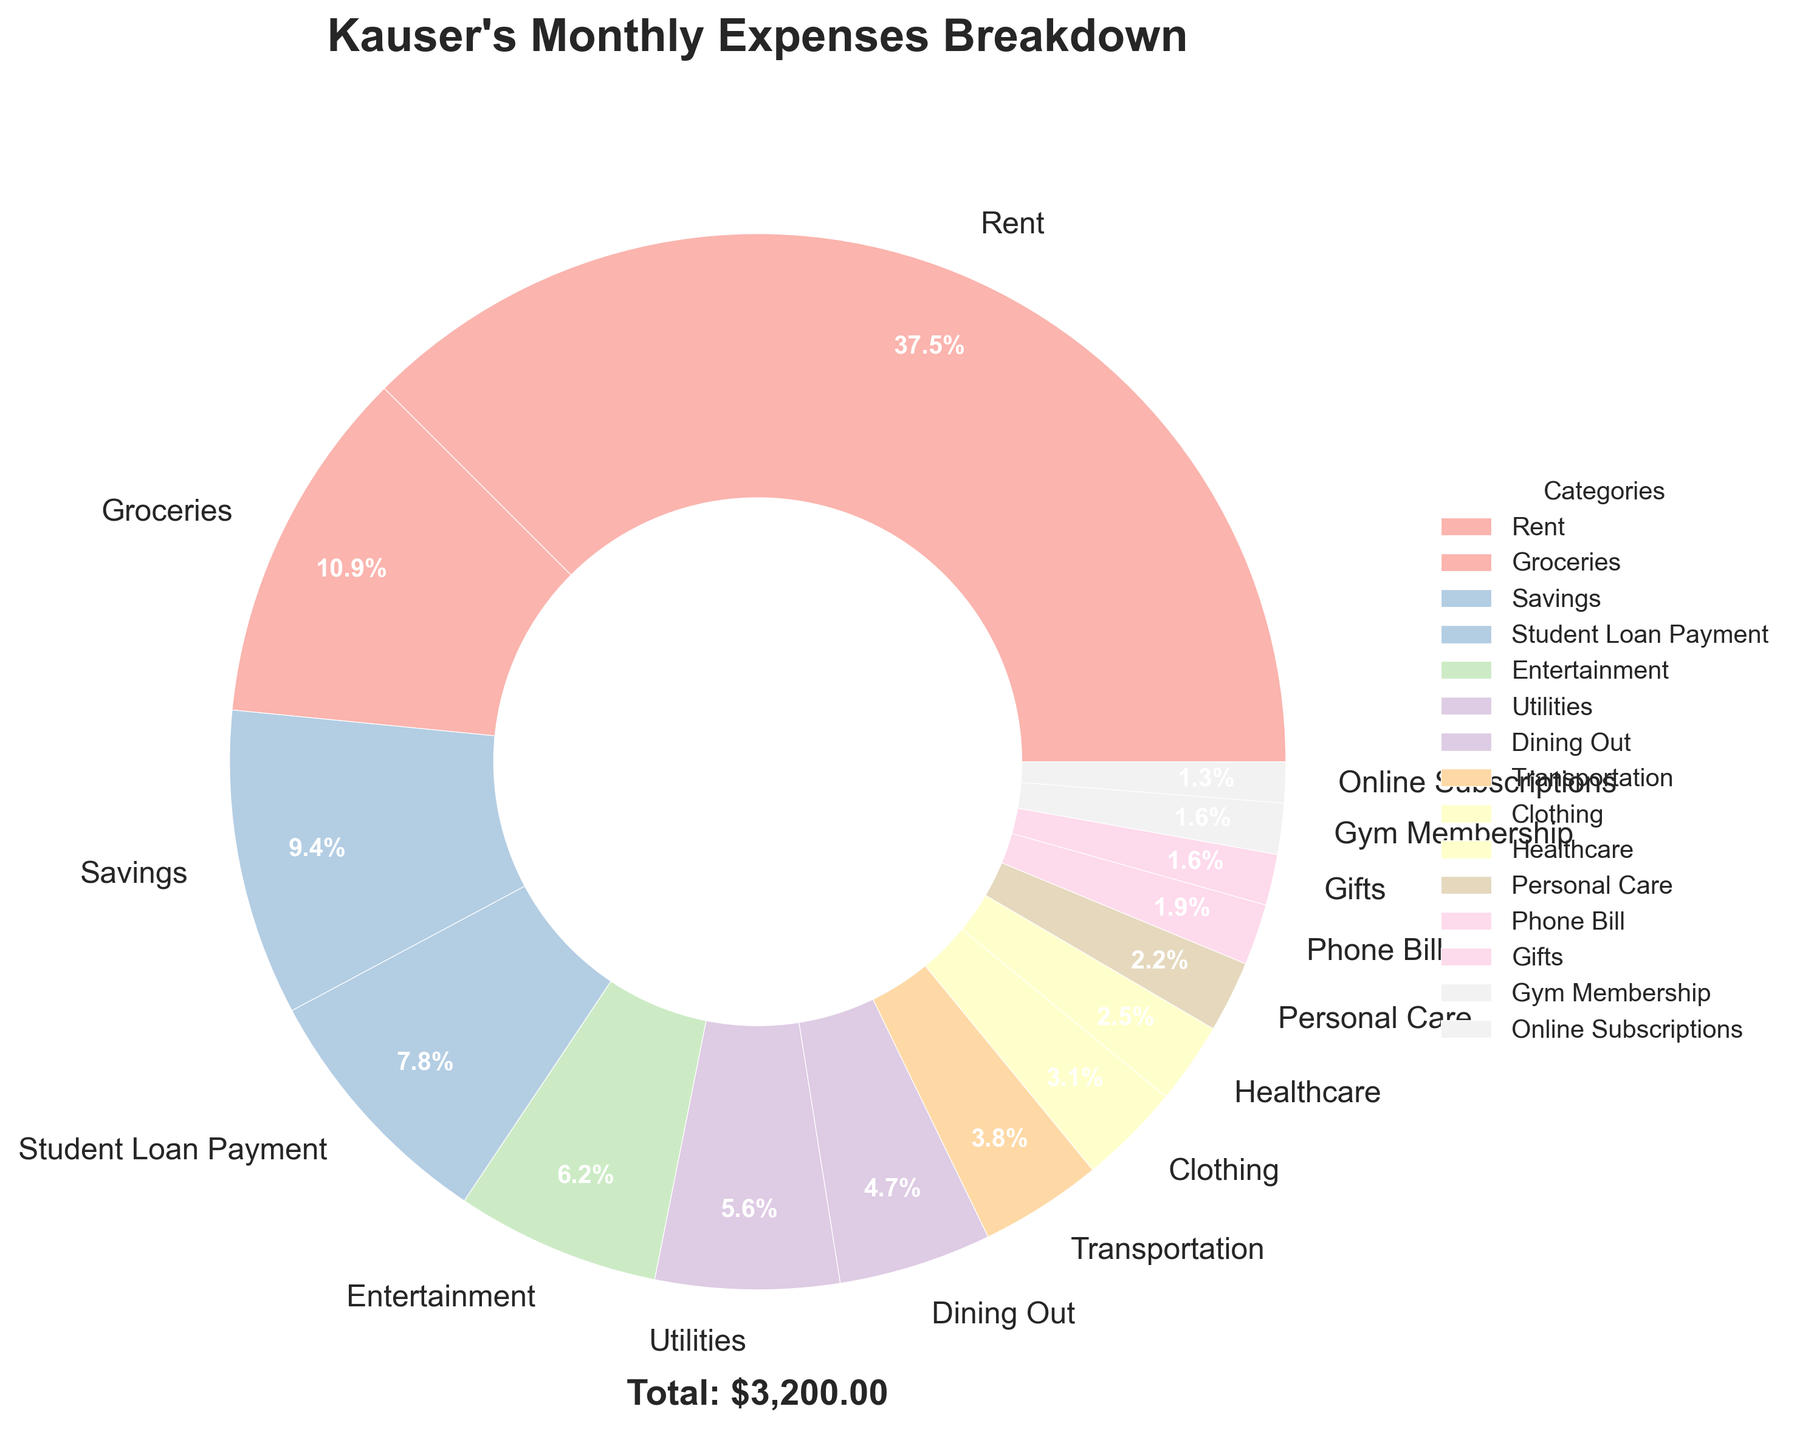What percentage of Kauser's monthly expenses is spent on rent? Rent is shown as a slice in the pie chart with a specific percentage. By looking at the visual representation labeled "Rent," you can directly see the percentage.
Answer: 41.7% How much more is spent on groceries compared to online subscriptions? The pie chart shows that groceries account for 12.1% and online subscriptions make up 1.4% of the total expenses. Calculating the difference in their actual amounts, we have $350 - $40 = $310.
Answer: $310 Which category has the smallest portion of Kauser's expenses, and what is the amount? Looking at the chart, the smallest slice corresponds to "Online Subscriptions" with a percentage and corresponding amount. This slice is visually the smallest among all the categories. The percentage can be cross-referenced to the actual amount ($40).
Answer: Online Subscriptions, $40 Arrange the top three expense categories in descending order? By looking at the size and percentage labels of the slices, the top three expense categories can be determined. Rent, Groceries, and Utilities are the largest slices.
Answer: Rent, Groceries, Entertainment How much does Kauser allocate for entertainment and dining out combined? The pie chart shows the percentage for Entertainment and Dining Out. The amounts are $200 for Entertainment and $150 for Dining Out. Adding them together gives $200 + $150 = $350.
Answer: $350 What is the difference between the amount spent on phone bills and transportation? The pie chart shows the actual amounts: $60 for Phone Bill and $120 for Transportation. The difference is calculated as $120 - $60 = $60.
Answer: $60 Which category has the second-largest expense? Visual inspection of the slices shows that after Rent, the next largest slice is "Groceries".
Answer: Groceries What fraction of the total monthly expenses is dedicated to dining out? Dining Out is represented by a slice with 5.2%. Converting this percentage to a fraction involves dividing by 100: 5.2/100 = 0.052.
Answer: 0.052 What is the combined total for the Personal Care and Gifts categories? Identifying and summing the amounts for Personal Care ($70) and Gifts ($50) from the chart gives $70 + $50 = $120.
Answer: $120 How many categories have expenses under $100? By visually inspecting the pie chart and noting the labeled amounts, categories with expenses under $100 include Online Subscriptions, Gym Membership, Phone Bill, Clothing, Healthcare, Personal Care, and Gifts. Counting these categories gives 7 categories.
Answer: 7 